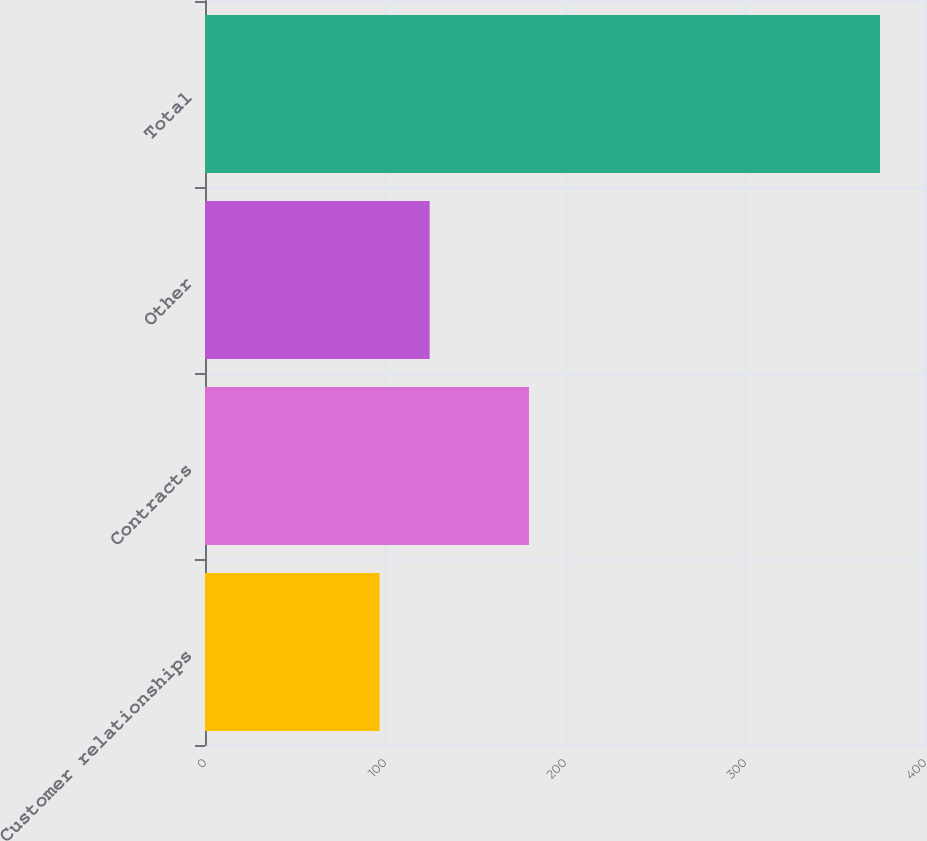Convert chart to OTSL. <chart><loc_0><loc_0><loc_500><loc_500><bar_chart><fcel>Customer relationships<fcel>Contracts<fcel>Other<fcel>Total<nl><fcel>97<fcel>180<fcel>124.8<fcel>375<nl></chart> 